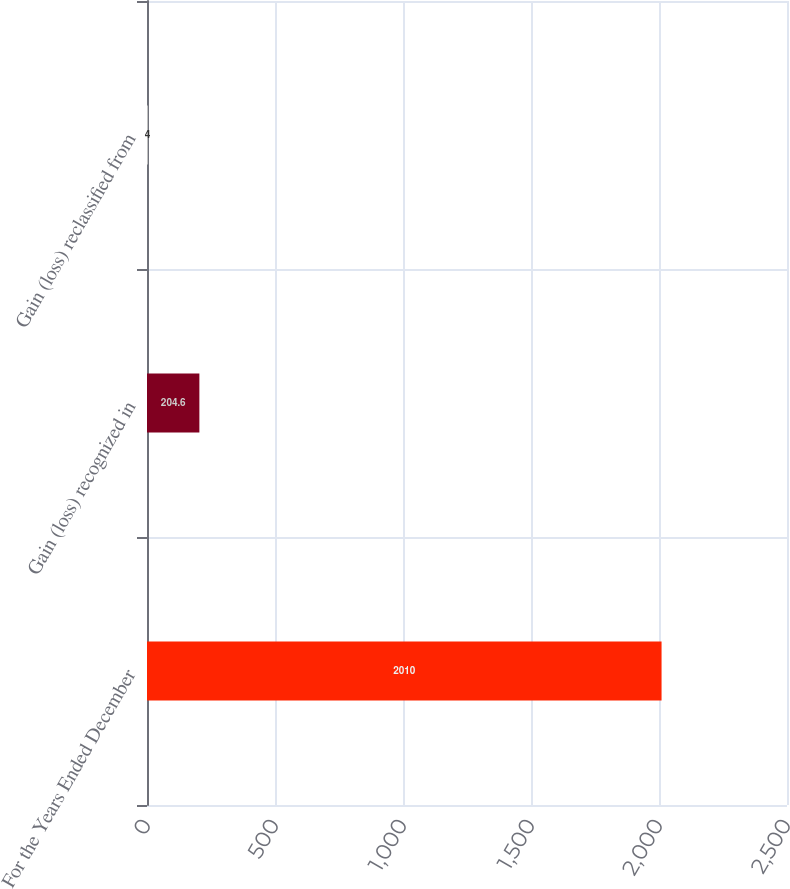Convert chart. <chart><loc_0><loc_0><loc_500><loc_500><bar_chart><fcel>For the Years Ended December<fcel>Gain (loss) recognized in<fcel>Gain (loss) reclassified from<nl><fcel>2010<fcel>204.6<fcel>4<nl></chart> 